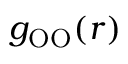Convert formula to latex. <formula><loc_0><loc_0><loc_500><loc_500>g _ { O O } ( r )</formula> 